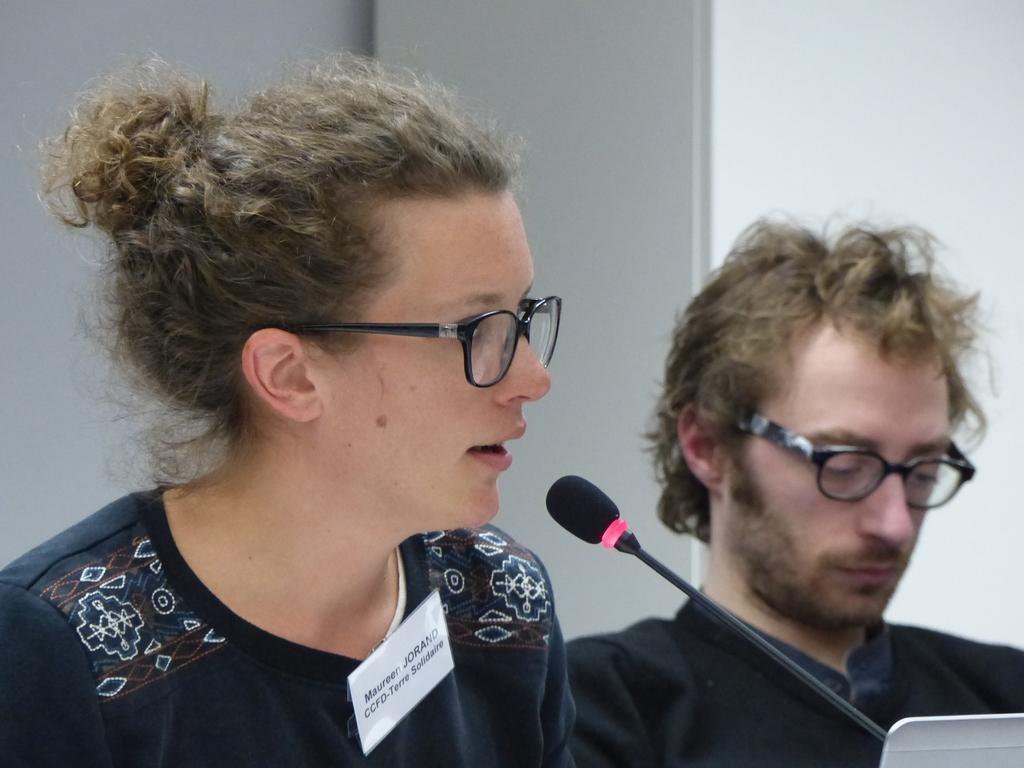Describe this image in one or two sentences. In this picture there is a woman talking and at the back there is a man. In the foreground there is a microphone. At the back there is a wall. 